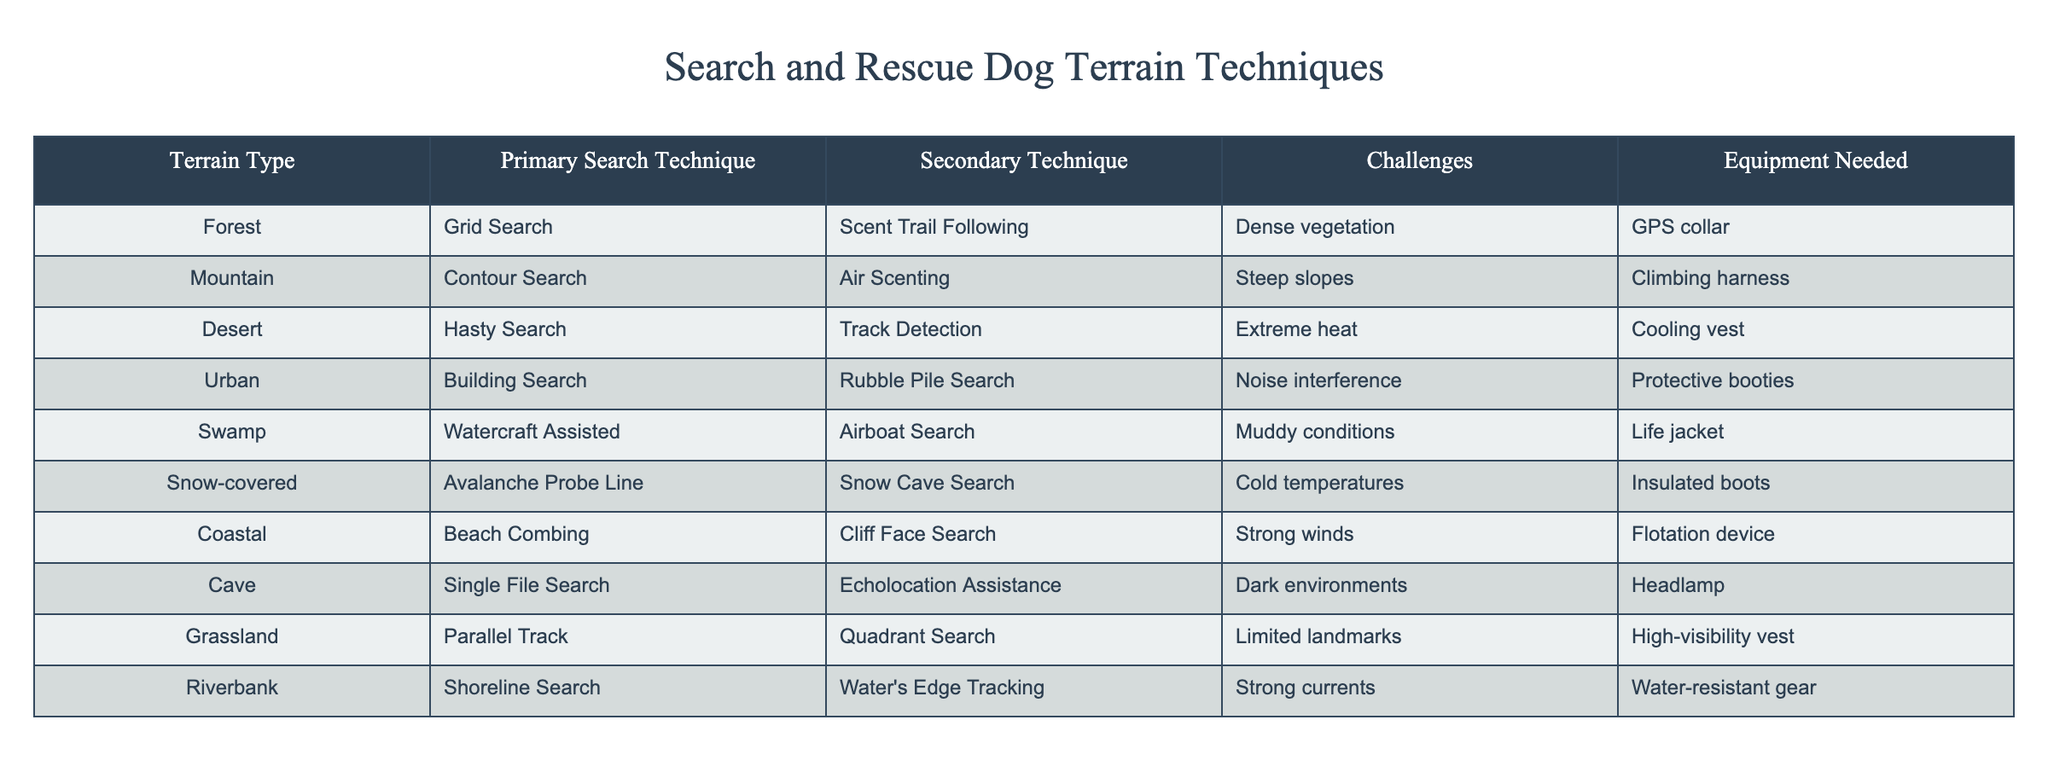What is the primary search technique for mountainous terrain? The table lists the primary search technique for mountainous terrain under the "Primary Search Technique" column for "Mountain." It shows that the primary technique is "Contour Search."
Answer: Contour Search Which terrain type has the challenge of dense vegetation? Referring to the "Challenges" column in the row corresponding to "Forest," it indicates that the challenge faced in this terrain is "Dense vegetation."
Answer: Dense vegetation Is "Scent Trail Following" a secondary technique for coastal terrain? By reviewing the table, "Scent Trail Following" is listed as a secondary technique for "Forest" terrain and not for "Coastal." Thus, the statement is false.
Answer: No How many terrain types have "Water" associated with their search techniques? Looking across the "Primary Search Technique" column, "Watercraft Assisted" and "Shoreline Search" are listed under "Swamp" and "Riverbank," respectively. This totals to two terrain types.
Answer: 2 What is the relationship between extreme heat and the associated search technique in deserts? The table shows that the primary search technique for "Desert" is "Hasty Search," and the challenge listed is "Extreme heat." This indicates that the heat is a significant factor impacting search techniques in this terrain.
Answer: Hasty Search Which terrain type has the least notable landmarks? The "Grassland" row mentions "Limited landmarks" as a challenge when applying search techniques, indicating it is the terrain type with the least notable landmarks.
Answer: Grassland If cold temperatures are a challenge for snow-covered terrain, which technique is primary? The "Snow-covered" terrain lists "Avalanche Probe Line" as the primary search technique while cold temperatures are listed as a challenge. Thus, the search technique is specifically tailored for those conditions.
Answer: Avalanche Probe Line In terms of equipment, which search technique requires a life jacket? The "Equipment Needed" column for "Swamp" terrain specifies that a life jacket is essential for "Watercraft Assisted," which is the primary search technique. This directly connects the need for a life jacket with this search technique.
Answer: Watercraft Assisted What is the secondary technique used for urban terrain? The row for "Urban" in the table indicates that the secondary technique is "Rubble Pile Search." Therefore, this is clearly the answer to the question regarding urban terrain techniques.
Answer: Rubble Pile Search 